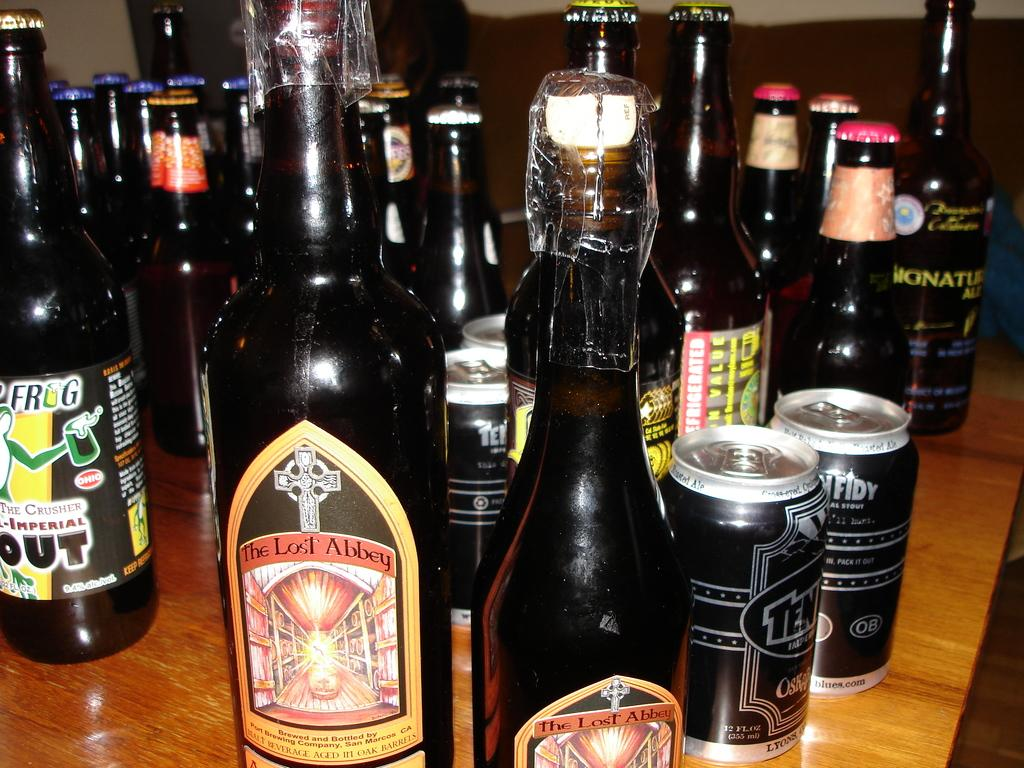<image>
Render a clear and concise summary of the photo. A bottle of beer has a label that says The Lost Abbey. 